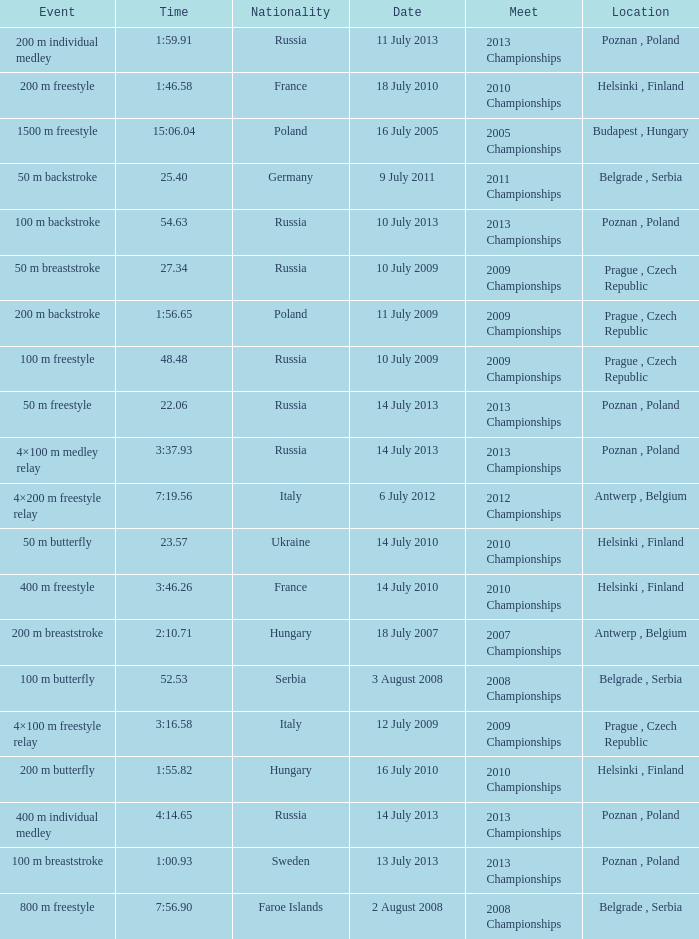What date was the 1500 m freestyle competition? 16 July 2005. 